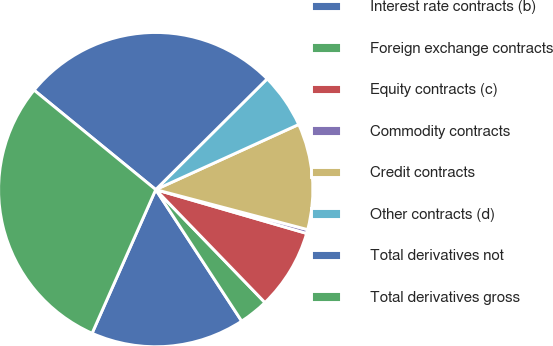Convert chart to OTSL. <chart><loc_0><loc_0><loc_500><loc_500><pie_chart><fcel>Interest rate contracts (b)<fcel>Foreign exchange contracts<fcel>Equity contracts (c)<fcel>Commodity contracts<fcel>Credit contracts<fcel>Other contracts (d)<fcel>Total derivatives not<fcel>Total derivatives gross<nl><fcel>15.85%<fcel>3.02%<fcel>8.27%<fcel>0.4%<fcel>10.9%<fcel>5.65%<fcel>26.64%<fcel>29.27%<nl></chart> 